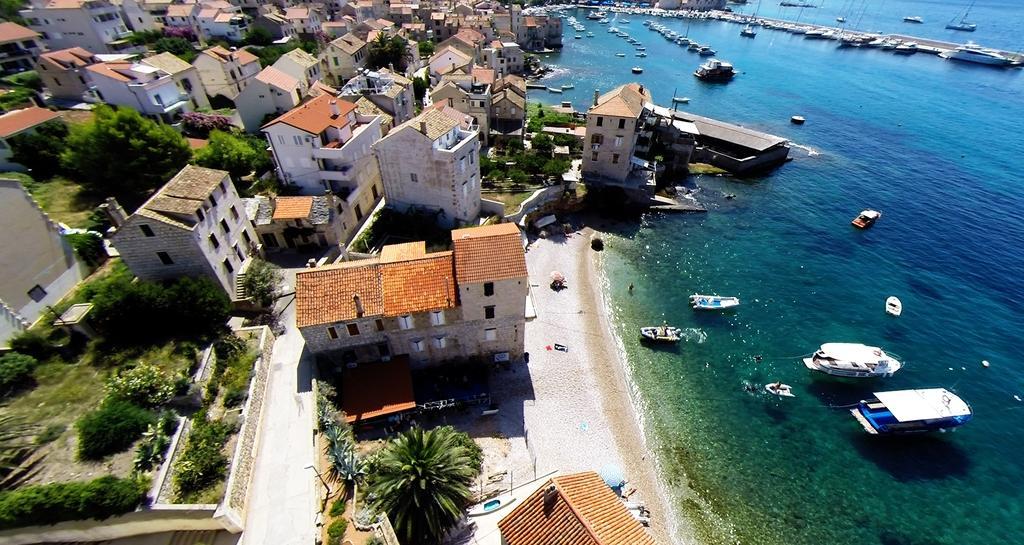In one or two sentences, can you explain what this image depicts? This image is taken outdoors. On the right side of the image there is a sea and there are many boats on the sea. On the left side of the image there are many buildings and houses with walls, windows, roofs, balconies and doors. There are many trees and plants on the ground and there are a few poles. There is a ground. 